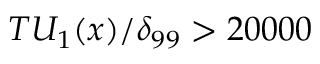Convert formula to latex. <formula><loc_0><loc_0><loc_500><loc_500>T U _ { 1 } ( x ) / \delta _ { 9 9 } > 2 0 0 0 0</formula> 